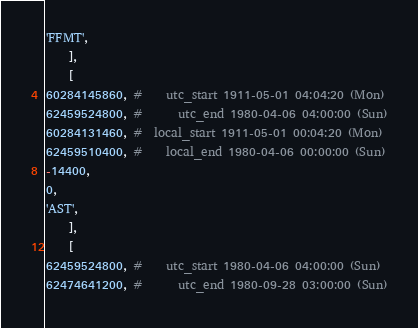<code> <loc_0><loc_0><loc_500><loc_500><_Perl_>'FFMT',
    ],
    [
60284145860, #    utc_start 1911-05-01 04:04:20 (Mon)
62459524800, #      utc_end 1980-04-06 04:00:00 (Sun)
60284131460, #  local_start 1911-05-01 00:04:20 (Mon)
62459510400, #    local_end 1980-04-06 00:00:00 (Sun)
-14400,
0,
'AST',
    ],
    [
62459524800, #    utc_start 1980-04-06 04:00:00 (Sun)
62474641200, #      utc_end 1980-09-28 03:00:00 (Sun)</code> 